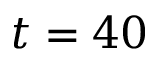Convert formula to latex. <formula><loc_0><loc_0><loc_500><loc_500>t = 4 0</formula> 